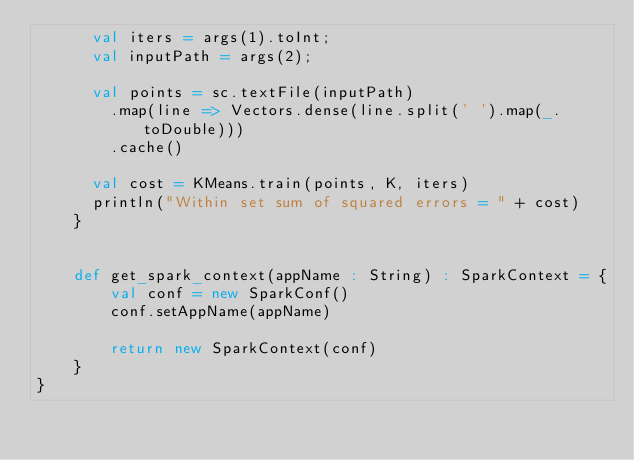Convert code to text. <code><loc_0><loc_0><loc_500><loc_500><_Scala_>      val iters = args(1).toInt;
      val inputPath = args(2);

      val points = sc.textFile(inputPath)
        .map(line => Vectors.dense(line.split(' ').map(_.toDouble)))
        .cache()

      val cost = KMeans.train(points, K, iters)
      println("Within set sum of squared errors = " + cost)
    }


    def get_spark_context(appName : String) : SparkContext = {
        val conf = new SparkConf()
        conf.setAppName(appName)
        
        return new SparkContext(conf)
    }
}
</code> 